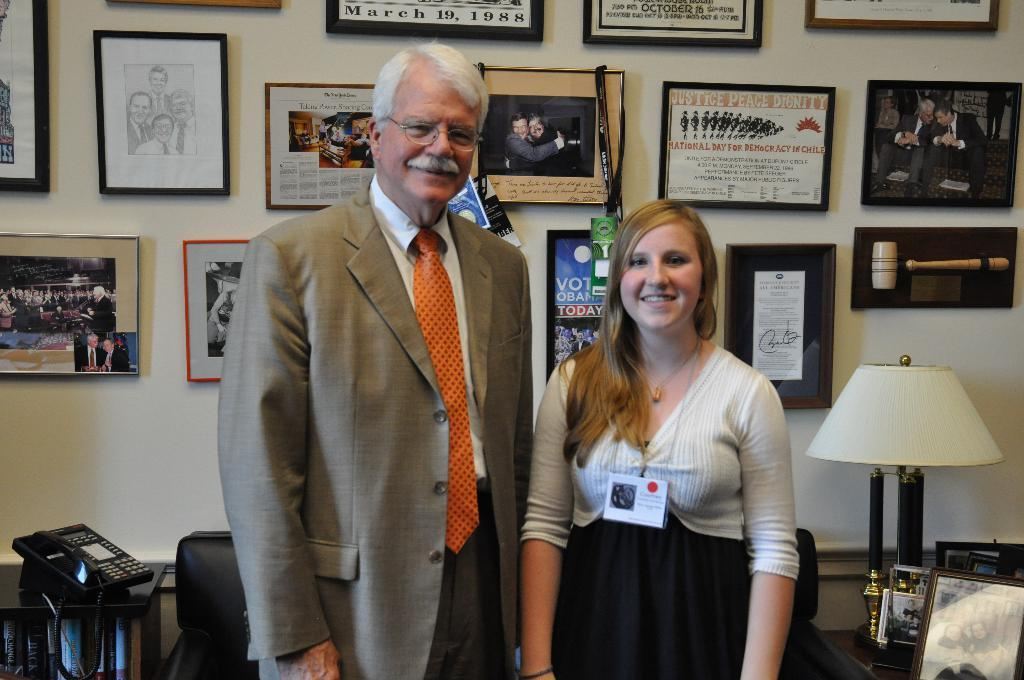<image>
Provide a brief description of the given image. A man and woman standing in front of plaques where one reads Vote Obama Today 